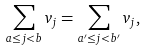Convert formula to latex. <formula><loc_0><loc_0><loc_500><loc_500>\sum _ { a \leq j < b } v _ { j } = \sum _ { a ^ { \prime } \leq j < b ^ { \prime } } v _ { j } ,</formula> 